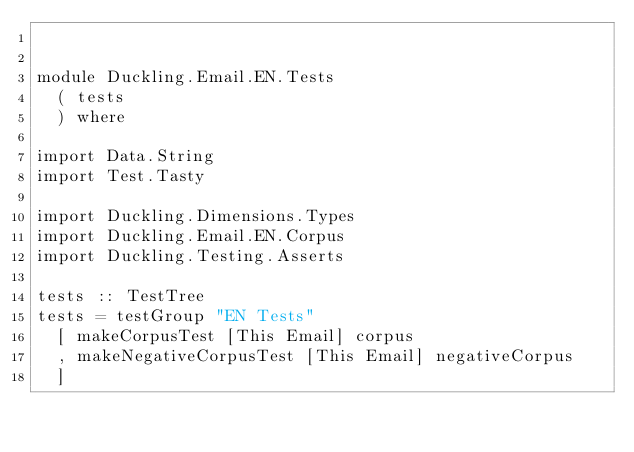<code> <loc_0><loc_0><loc_500><loc_500><_Haskell_>

module Duckling.Email.EN.Tests
  ( tests
  ) where

import Data.String
import Test.Tasty

import Duckling.Dimensions.Types
import Duckling.Email.EN.Corpus
import Duckling.Testing.Asserts

tests :: TestTree
tests = testGroup "EN Tests"
  [ makeCorpusTest [This Email] corpus
  , makeNegativeCorpusTest [This Email] negativeCorpus
  ]
</code> 